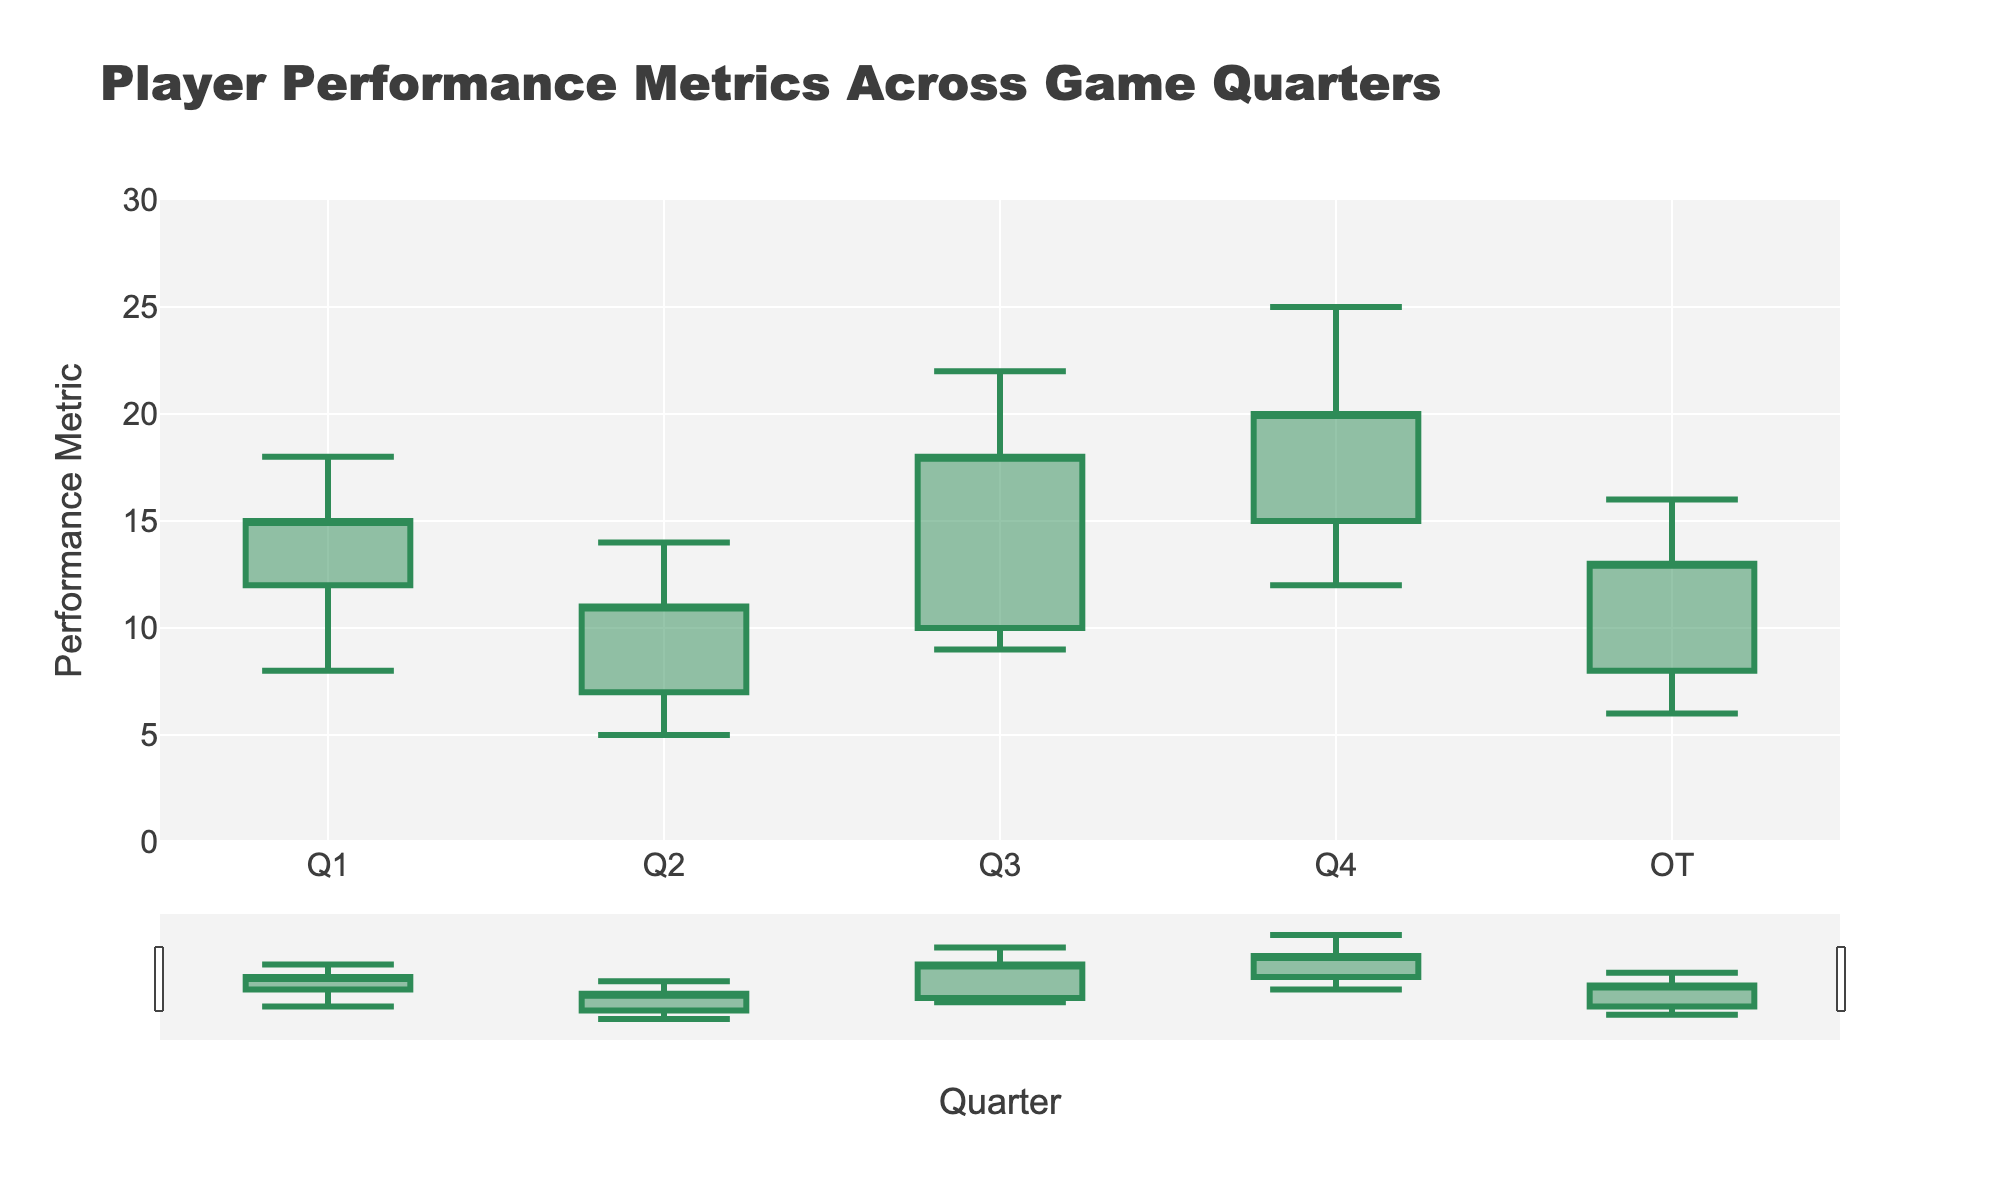What's the title of the chart? The title of the chart is located at the top and indicates what the chart is about. Here, it reads "Player Performance Metrics Across Game Quarters."
Answer: Player Performance Metrics Across Game Quarters What's the high value for Ja Morant in the third quarter? The OHLC chart shows a different value for each parameter (Open, High, Low, Close) in the form of the candlestick. The high value for Ja Morant, represented in the third quarter, is the highest point of the candlestick. The chart shows it as 22.
Answer: 22 Which player had the highest performance metric across all quarters and what was that value? To find the highest performance metric, identify the highest "high" value across all quarters and check the corresponding player. The player Anthony Edwards in the fourth quarter had the highest value, which is 25.
Answer: Anthony Edwards, 25 How does Zion Williamson's Low value compare to Cade Cunningham's Low value? Compare the Low values of Zion Williamson and Cade Cunningham by looking at their respective quarters (Q1 and Q2). Zion's Low value is 8, and Cade's is 5. Therefore, Zion's Low is higher.
Answer: Zion Williamson's Low is higher What is the average of the High values across all players? Add up all the High values for each player and divide by the number of players: (18 + 14 + 22 + 25 + 16) / 5. This calculation gives the average performance metric for the High values.
Answer: 19 Which quarter saw LaMelo Ball play, and what were his Open and Close values? LaMelo Ball is listed for the OT quarter. The Open and Close values are given at the ends of the corresponding candlestick for that quarter. The Open value is 8, and the Close value is 13.
Answer: OT, Open: 8, Close: 13 What's the difference between the High and Low values for Anthony Edwards? To find the difference, subtract the Low value from the High value for Anthony Edwards in the fourth quarter: 25 - 12. This gives the range of performance for him in that quarter.
Answer: 13 Who had the lowest Close value, and what was it? Identify the minimum Close values for all players. Cade Cunningham in the second quarter had the lowest Close value, which is 11.
Answer: Cade Cunningham, 11 What is the range (difference between High and Low) in performance for Zion Williamson in the first quarter? Calculate the range by subtracting the Low value from the High value for Zion Williamson in the first quarter: 18 - 8.
Answer: 10 How did Anthony Edwards' performance metric change from the Open to the Close value in the fourth quarter? Subtract the Open value from the Close value for Anthony Edwards: 20 - 15. This shows how his performance metric increased or decreased.
Answer: Increased by 5 